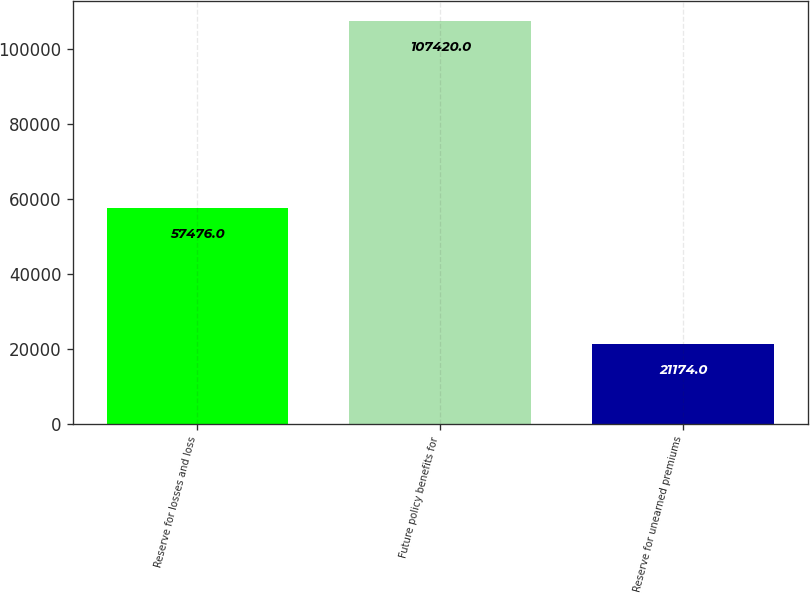Convert chart. <chart><loc_0><loc_0><loc_500><loc_500><bar_chart><fcel>Reserve for losses and loss<fcel>Future policy benefits for<fcel>Reserve for unearned premiums<nl><fcel>57476<fcel>107420<fcel>21174<nl></chart> 